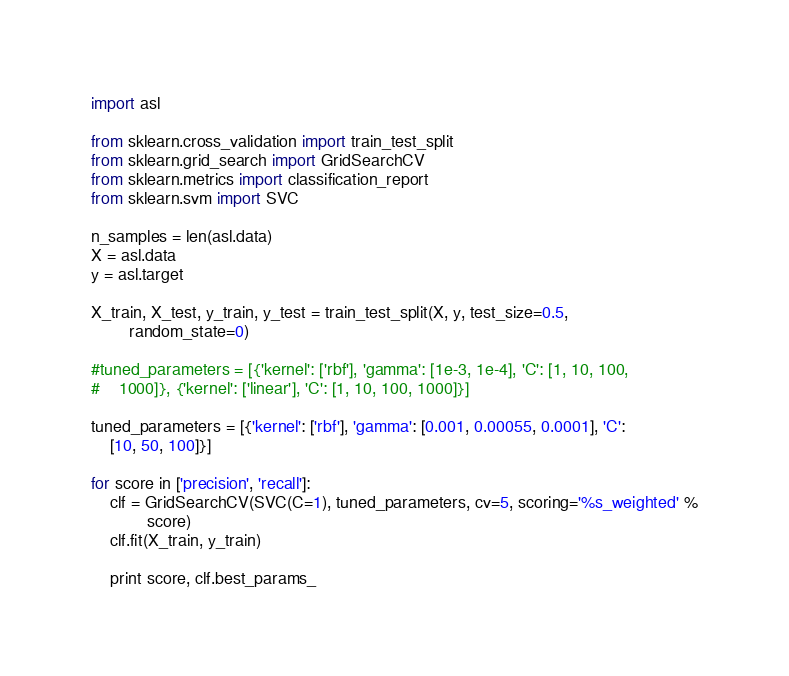Convert code to text. <code><loc_0><loc_0><loc_500><loc_500><_Python_>import asl

from sklearn.cross_validation import train_test_split
from sklearn.grid_search import GridSearchCV
from sklearn.metrics import classification_report
from sklearn.svm import SVC

n_samples = len(asl.data)
X = asl.data
y = asl.target

X_train, X_test, y_train, y_test = train_test_split(X, y, test_size=0.5,
        random_state=0)

#tuned_parameters = [{'kernel': ['rbf'], 'gamma': [1e-3, 1e-4], 'C': [1, 10, 100,
#    1000]}, {'kernel': ['linear'], 'C': [1, 10, 100, 1000]}]

tuned_parameters = [{'kernel': ['rbf'], 'gamma': [0.001, 0.00055, 0.0001], 'C':
    [10, 50, 100]}]

for score in ['precision', 'recall']:
    clf = GridSearchCV(SVC(C=1), tuned_parameters, cv=5, scoring='%s_weighted' %
            score)
    clf.fit(X_train, y_train)

    print score, clf.best_params_
</code> 